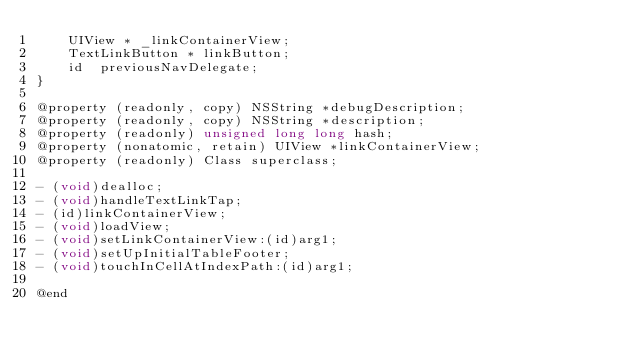<code> <loc_0><loc_0><loc_500><loc_500><_C_>    UIView * _linkContainerView;
    TextLinkButton * linkButton;
    id  previousNavDelegate;
}

@property (readonly, copy) NSString *debugDescription;
@property (readonly, copy) NSString *description;
@property (readonly) unsigned long long hash;
@property (nonatomic, retain) UIView *linkContainerView;
@property (readonly) Class superclass;

- (void)dealloc;
- (void)handleTextLinkTap;
- (id)linkContainerView;
- (void)loadView;
- (void)setLinkContainerView:(id)arg1;
- (void)setUpInitialTableFooter;
- (void)touchInCellAtIndexPath:(id)arg1;

@end
</code> 